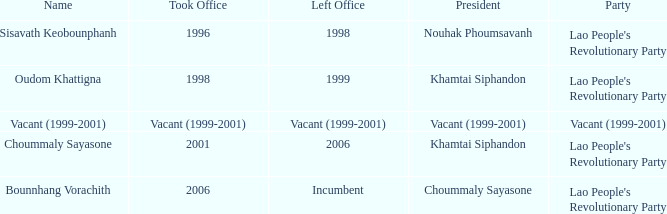What is Name, when President is Khamtai Siphandon, and when Left Office is 1999? Oudom Khattigna. 